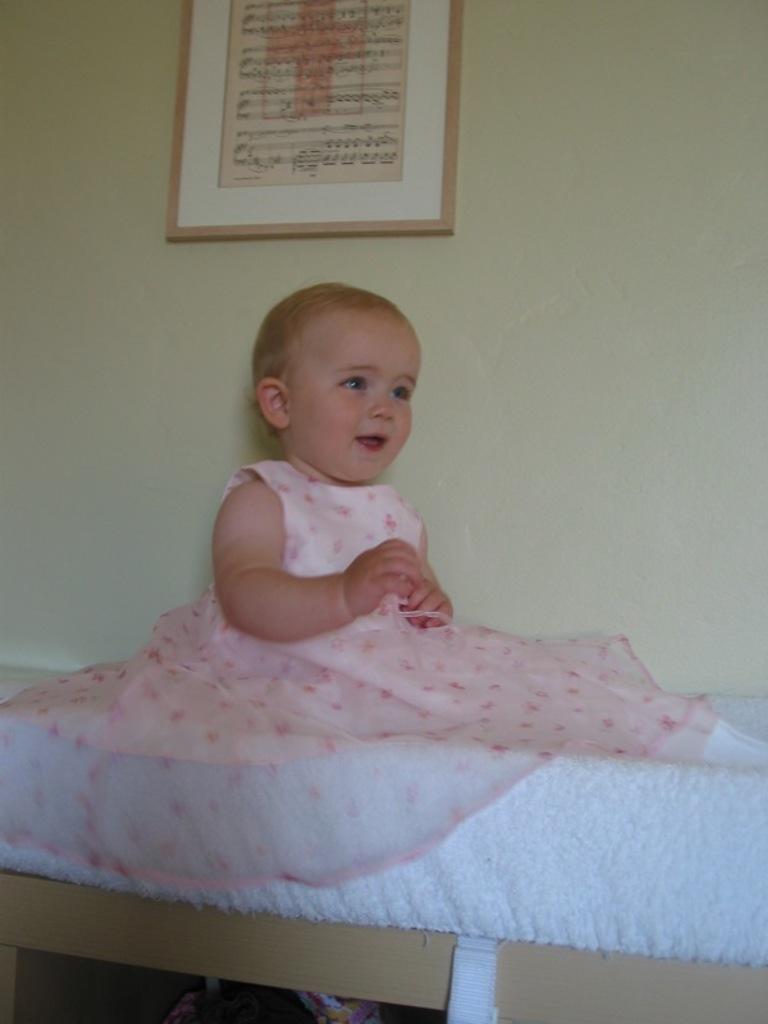Please provide a concise description of this image. In this image there is a toddler sitting on the bed, beside the bed on the wall there is a photo frame, beneath the bed there are some objects. 